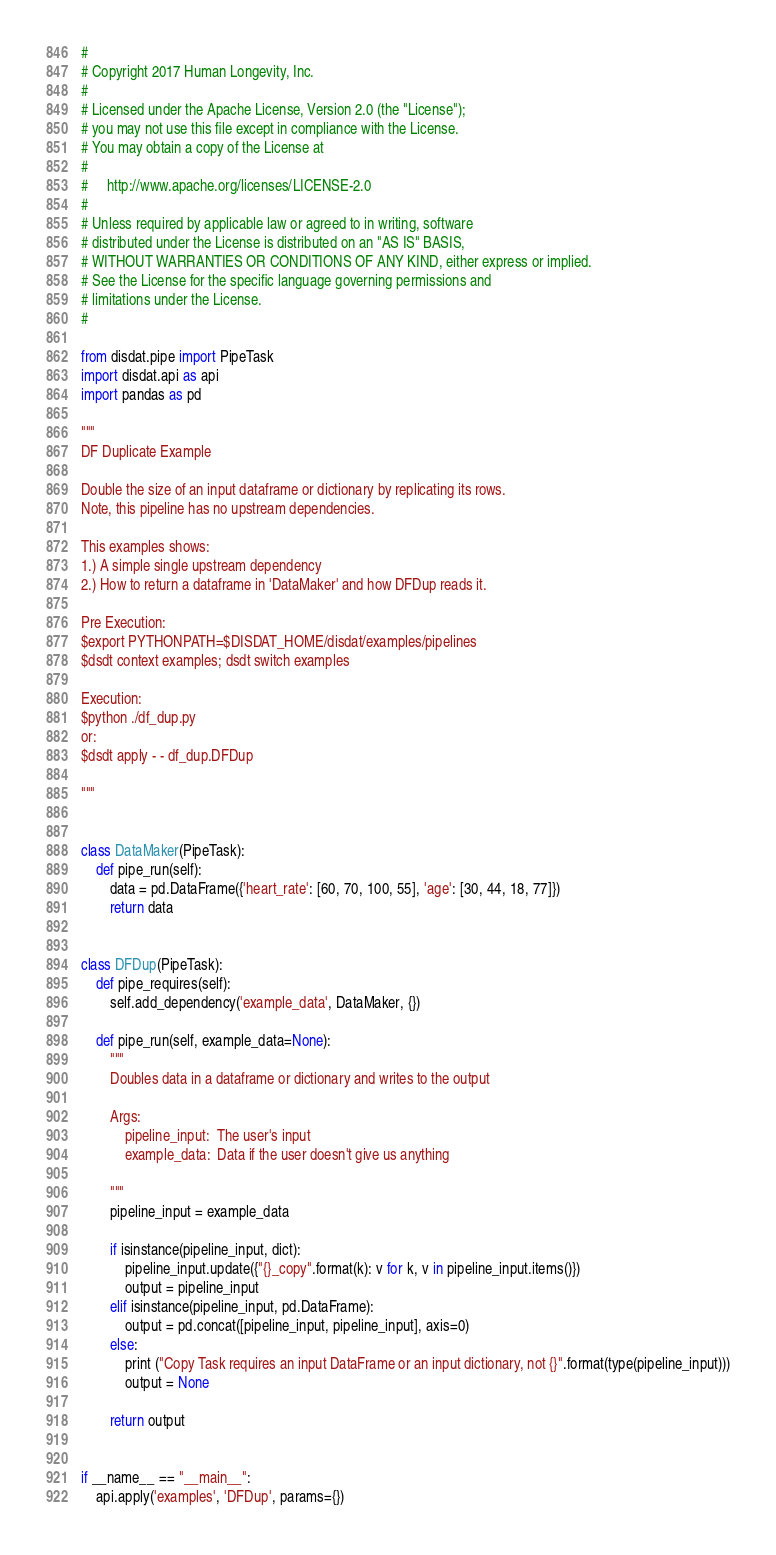<code> <loc_0><loc_0><loc_500><loc_500><_Python_>#
# Copyright 2017 Human Longevity, Inc.
#
# Licensed under the Apache License, Version 2.0 (the "License");
# you may not use this file except in compliance with the License.
# You may obtain a copy of the License at
#
#     http://www.apache.org/licenses/LICENSE-2.0
#
# Unless required by applicable law or agreed to in writing, software
# distributed under the License is distributed on an "AS IS" BASIS,
# WITHOUT WARRANTIES OR CONDITIONS OF ANY KIND, either express or implied.
# See the License for the specific language governing permissions and
# limitations under the License.
#

from disdat.pipe import PipeTask
import disdat.api as api
import pandas as pd

"""
DF Duplicate Example

Double the size of an input dataframe or dictionary by replicating its rows.
Note, this pipeline has no upstream dependencies.

This examples shows:
1.) A simple single upstream dependency
2.) How to return a dataframe in 'DataMaker' and how DFDup reads it.

Pre Execution:
$export PYTHONPATH=$DISDAT_HOME/disdat/examples/pipelines
$dsdt context examples; dsdt switch examples

Execution:
$python ./df_dup.py
or:
$dsdt apply - - df_dup.DFDup

"""


class DataMaker(PipeTask):
    def pipe_run(self):
        data = pd.DataFrame({'heart_rate': [60, 70, 100, 55], 'age': [30, 44, 18, 77]})
        return data


class DFDup(PipeTask):
    def pipe_requires(self):
        self.add_dependency('example_data', DataMaker, {})

    def pipe_run(self, example_data=None):
        """
        Doubles data in a dataframe or dictionary and writes to the output

        Args:
            pipeline_input:  The user's input
            example_data:  Data if the user doesn't give us anything

        """
        pipeline_input = example_data

        if isinstance(pipeline_input, dict):
            pipeline_input.update({"{}_copy".format(k): v for k, v in pipeline_input.items()})
            output = pipeline_input
        elif isinstance(pipeline_input, pd.DataFrame):
            output = pd.concat([pipeline_input, pipeline_input], axis=0)
        else:
            print ("Copy Task requires an input DataFrame or an input dictionary, not {}".format(type(pipeline_input)))
            output = None

        return output


if __name__ == "__main__":
    api.apply('examples', 'DFDup', params={})
</code> 